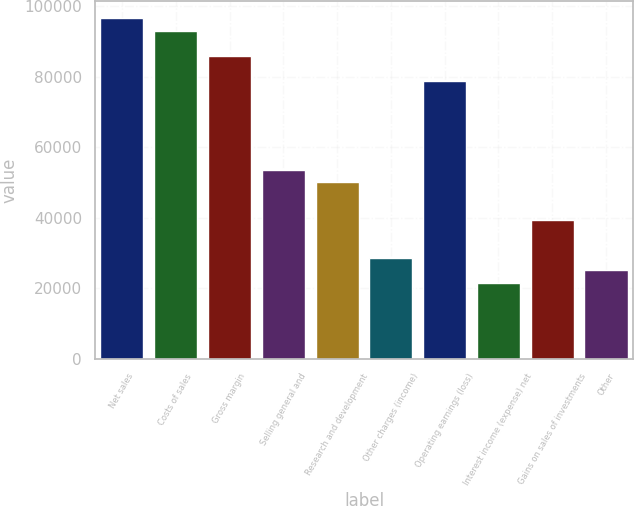Convert chart to OTSL. <chart><loc_0><loc_0><loc_500><loc_500><bar_chart><fcel>Net sales<fcel>Costs of sales<fcel>Gross margin<fcel>Selling general and<fcel>Research and development<fcel>Other charges (income)<fcel>Operating earnings (loss)<fcel>Interest income (expense) net<fcel>Gains on sales of investments<fcel>Other<nl><fcel>96665<fcel>93084.8<fcel>85924.5<fcel>53702.9<fcel>50122.7<fcel>28641.6<fcel>78764.1<fcel>21481.2<fcel>39382.1<fcel>25061.4<nl></chart> 